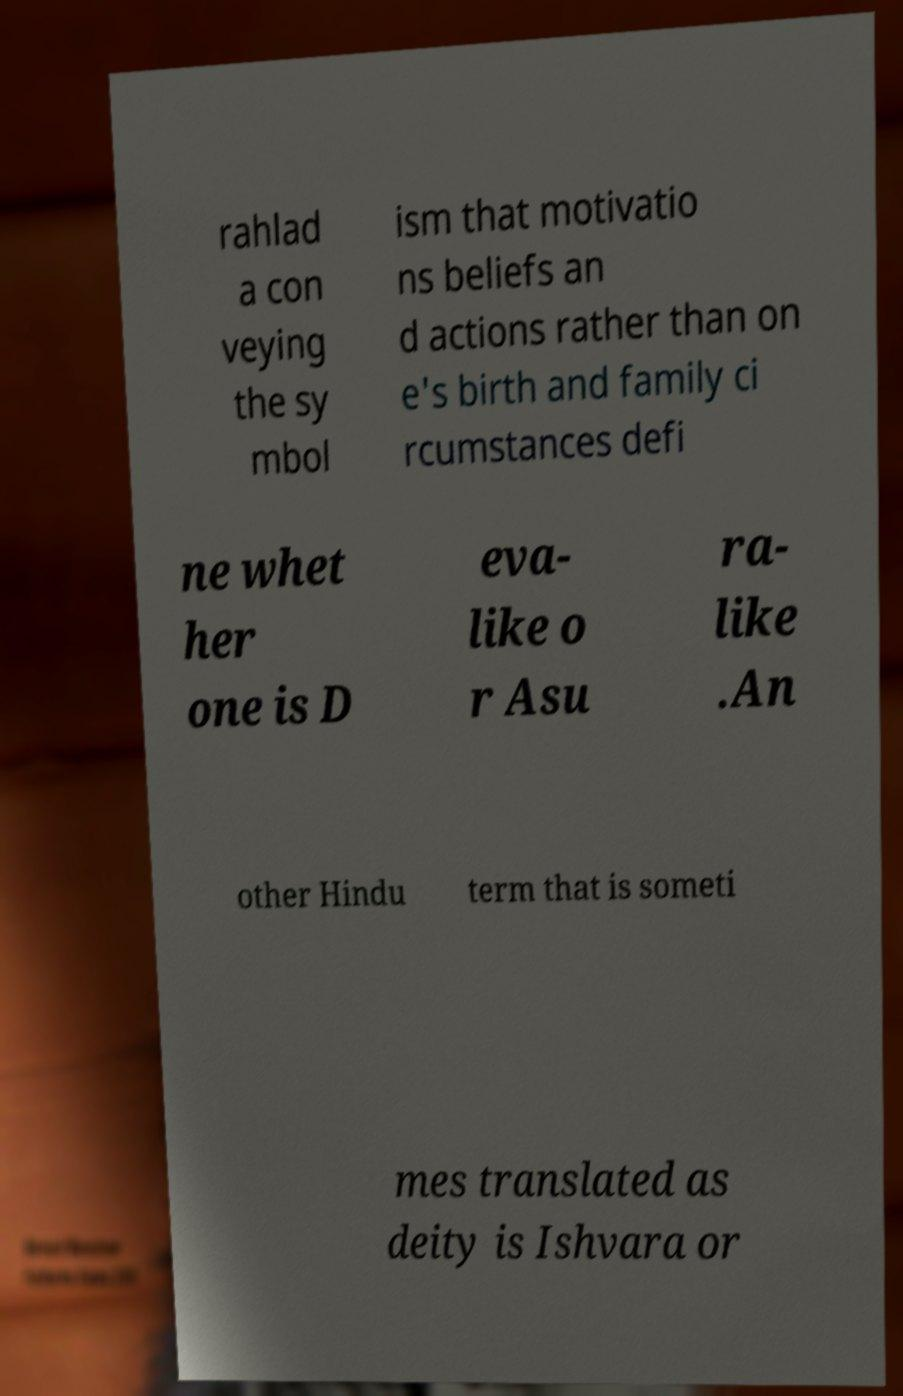Can you read and provide the text displayed in the image?This photo seems to have some interesting text. Can you extract and type it out for me? rahlad a con veying the sy mbol ism that motivatio ns beliefs an d actions rather than on e's birth and family ci rcumstances defi ne whet her one is D eva- like o r Asu ra- like .An other Hindu term that is someti mes translated as deity is Ishvara or 